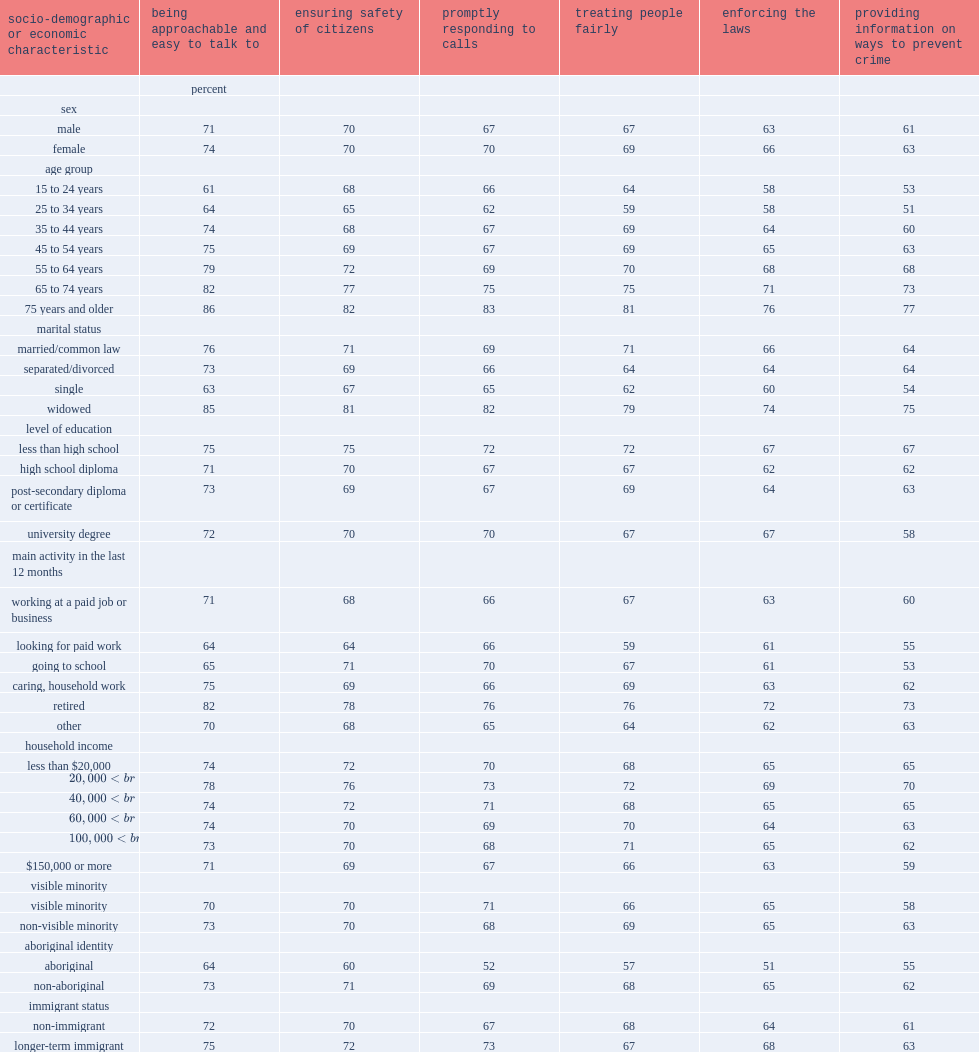Which group of people is more likely to rated police higher on promptly responding to calls? visible minorities or non-visible minorities. Visible minority. Which group of people is more likely to rated police lower on the elements of policing involving interpersonal relationships - being approachable and easy to talk to and treating people fairly? visible minorities or non-visible minorities. Visible minority. Which group of people is more likely to rated police lower on all of the six police performance measures ? aboriginal people or non-aboriginal people? Aboriginal. 